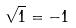<formula> <loc_0><loc_0><loc_500><loc_500>\sqrt { 1 } = - 1</formula> 